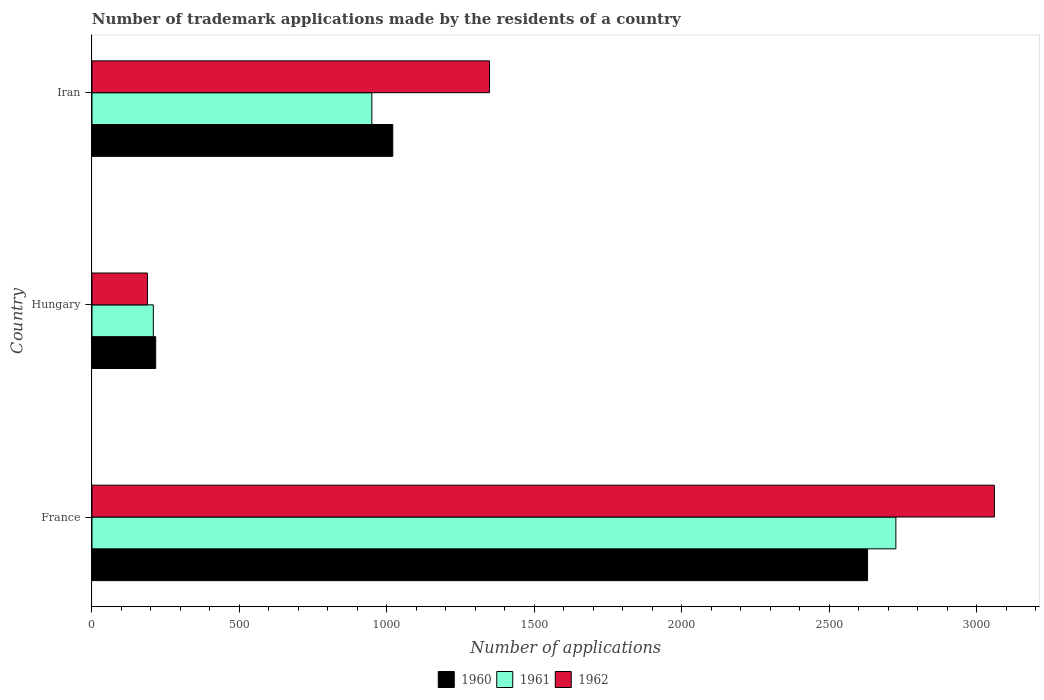Are the number of bars on each tick of the Y-axis equal?
Your answer should be compact. Yes. How many bars are there on the 3rd tick from the top?
Ensure brevity in your answer.  3. How many bars are there on the 2nd tick from the bottom?
Your answer should be very brief. 3. What is the label of the 1st group of bars from the top?
Offer a terse response. Iran. What is the number of trademark applications made by the residents in 1961 in France?
Offer a very short reply. 2726. Across all countries, what is the maximum number of trademark applications made by the residents in 1960?
Keep it short and to the point. 2630. Across all countries, what is the minimum number of trademark applications made by the residents in 1962?
Your answer should be very brief. 188. In which country was the number of trademark applications made by the residents in 1962 maximum?
Give a very brief answer. France. In which country was the number of trademark applications made by the residents in 1961 minimum?
Provide a succinct answer. Hungary. What is the total number of trademark applications made by the residents in 1960 in the graph?
Your answer should be compact. 3866. What is the difference between the number of trademark applications made by the residents in 1962 in Hungary and that in Iran?
Offer a terse response. -1160. What is the difference between the number of trademark applications made by the residents in 1960 in France and the number of trademark applications made by the residents in 1961 in Hungary?
Make the answer very short. 2422. What is the average number of trademark applications made by the residents in 1961 per country?
Offer a very short reply. 1294.33. What is the difference between the number of trademark applications made by the residents in 1962 and number of trademark applications made by the residents in 1961 in Iran?
Keep it short and to the point. 399. In how many countries, is the number of trademark applications made by the residents in 1961 greater than 500 ?
Ensure brevity in your answer.  2. What is the ratio of the number of trademark applications made by the residents in 1960 in France to that in Hungary?
Your answer should be compact. 12.18. Is the number of trademark applications made by the residents in 1960 in France less than that in Hungary?
Ensure brevity in your answer.  No. What is the difference between the highest and the second highest number of trademark applications made by the residents in 1961?
Offer a terse response. 1777. What is the difference between the highest and the lowest number of trademark applications made by the residents in 1961?
Make the answer very short. 2518. In how many countries, is the number of trademark applications made by the residents in 1962 greater than the average number of trademark applications made by the residents in 1962 taken over all countries?
Keep it short and to the point. 1. What does the 2nd bar from the top in Hungary represents?
Your answer should be very brief. 1961. Is it the case that in every country, the sum of the number of trademark applications made by the residents in 1962 and number of trademark applications made by the residents in 1961 is greater than the number of trademark applications made by the residents in 1960?
Offer a terse response. Yes. What is the difference between two consecutive major ticks on the X-axis?
Your answer should be compact. 500. Are the values on the major ticks of X-axis written in scientific E-notation?
Your response must be concise. No. Does the graph contain grids?
Your response must be concise. No. Where does the legend appear in the graph?
Offer a very short reply. Bottom center. What is the title of the graph?
Provide a succinct answer. Number of trademark applications made by the residents of a country. What is the label or title of the X-axis?
Make the answer very short. Number of applications. What is the Number of applications of 1960 in France?
Make the answer very short. 2630. What is the Number of applications of 1961 in France?
Your answer should be compact. 2726. What is the Number of applications in 1962 in France?
Your answer should be compact. 3060. What is the Number of applications of 1960 in Hungary?
Give a very brief answer. 216. What is the Number of applications in 1961 in Hungary?
Keep it short and to the point. 208. What is the Number of applications in 1962 in Hungary?
Offer a very short reply. 188. What is the Number of applications of 1960 in Iran?
Make the answer very short. 1020. What is the Number of applications in 1961 in Iran?
Keep it short and to the point. 949. What is the Number of applications of 1962 in Iran?
Make the answer very short. 1348. Across all countries, what is the maximum Number of applications of 1960?
Keep it short and to the point. 2630. Across all countries, what is the maximum Number of applications of 1961?
Provide a short and direct response. 2726. Across all countries, what is the maximum Number of applications of 1962?
Offer a very short reply. 3060. Across all countries, what is the minimum Number of applications in 1960?
Make the answer very short. 216. Across all countries, what is the minimum Number of applications of 1961?
Provide a succinct answer. 208. Across all countries, what is the minimum Number of applications in 1962?
Ensure brevity in your answer.  188. What is the total Number of applications of 1960 in the graph?
Make the answer very short. 3866. What is the total Number of applications in 1961 in the graph?
Keep it short and to the point. 3883. What is the total Number of applications of 1962 in the graph?
Provide a short and direct response. 4596. What is the difference between the Number of applications in 1960 in France and that in Hungary?
Provide a succinct answer. 2414. What is the difference between the Number of applications of 1961 in France and that in Hungary?
Make the answer very short. 2518. What is the difference between the Number of applications in 1962 in France and that in Hungary?
Give a very brief answer. 2872. What is the difference between the Number of applications of 1960 in France and that in Iran?
Give a very brief answer. 1610. What is the difference between the Number of applications in 1961 in France and that in Iran?
Provide a short and direct response. 1777. What is the difference between the Number of applications of 1962 in France and that in Iran?
Give a very brief answer. 1712. What is the difference between the Number of applications of 1960 in Hungary and that in Iran?
Provide a succinct answer. -804. What is the difference between the Number of applications in 1961 in Hungary and that in Iran?
Your answer should be compact. -741. What is the difference between the Number of applications of 1962 in Hungary and that in Iran?
Your response must be concise. -1160. What is the difference between the Number of applications in 1960 in France and the Number of applications in 1961 in Hungary?
Give a very brief answer. 2422. What is the difference between the Number of applications in 1960 in France and the Number of applications in 1962 in Hungary?
Provide a succinct answer. 2442. What is the difference between the Number of applications of 1961 in France and the Number of applications of 1962 in Hungary?
Your response must be concise. 2538. What is the difference between the Number of applications in 1960 in France and the Number of applications in 1961 in Iran?
Offer a very short reply. 1681. What is the difference between the Number of applications in 1960 in France and the Number of applications in 1962 in Iran?
Offer a terse response. 1282. What is the difference between the Number of applications in 1961 in France and the Number of applications in 1962 in Iran?
Offer a terse response. 1378. What is the difference between the Number of applications of 1960 in Hungary and the Number of applications of 1961 in Iran?
Make the answer very short. -733. What is the difference between the Number of applications in 1960 in Hungary and the Number of applications in 1962 in Iran?
Keep it short and to the point. -1132. What is the difference between the Number of applications in 1961 in Hungary and the Number of applications in 1962 in Iran?
Provide a succinct answer. -1140. What is the average Number of applications of 1960 per country?
Offer a very short reply. 1288.67. What is the average Number of applications of 1961 per country?
Your response must be concise. 1294.33. What is the average Number of applications in 1962 per country?
Offer a very short reply. 1532. What is the difference between the Number of applications in 1960 and Number of applications in 1961 in France?
Keep it short and to the point. -96. What is the difference between the Number of applications of 1960 and Number of applications of 1962 in France?
Your answer should be compact. -430. What is the difference between the Number of applications in 1961 and Number of applications in 1962 in France?
Your response must be concise. -334. What is the difference between the Number of applications in 1960 and Number of applications in 1961 in Hungary?
Provide a short and direct response. 8. What is the difference between the Number of applications of 1960 and Number of applications of 1962 in Iran?
Make the answer very short. -328. What is the difference between the Number of applications of 1961 and Number of applications of 1962 in Iran?
Offer a very short reply. -399. What is the ratio of the Number of applications in 1960 in France to that in Hungary?
Your answer should be very brief. 12.18. What is the ratio of the Number of applications of 1961 in France to that in Hungary?
Keep it short and to the point. 13.11. What is the ratio of the Number of applications of 1962 in France to that in Hungary?
Ensure brevity in your answer.  16.28. What is the ratio of the Number of applications in 1960 in France to that in Iran?
Give a very brief answer. 2.58. What is the ratio of the Number of applications of 1961 in France to that in Iran?
Your answer should be very brief. 2.87. What is the ratio of the Number of applications of 1962 in France to that in Iran?
Offer a very short reply. 2.27. What is the ratio of the Number of applications in 1960 in Hungary to that in Iran?
Ensure brevity in your answer.  0.21. What is the ratio of the Number of applications of 1961 in Hungary to that in Iran?
Your response must be concise. 0.22. What is the ratio of the Number of applications in 1962 in Hungary to that in Iran?
Offer a terse response. 0.14. What is the difference between the highest and the second highest Number of applications in 1960?
Your response must be concise. 1610. What is the difference between the highest and the second highest Number of applications in 1961?
Make the answer very short. 1777. What is the difference between the highest and the second highest Number of applications of 1962?
Keep it short and to the point. 1712. What is the difference between the highest and the lowest Number of applications in 1960?
Make the answer very short. 2414. What is the difference between the highest and the lowest Number of applications in 1961?
Your answer should be compact. 2518. What is the difference between the highest and the lowest Number of applications of 1962?
Keep it short and to the point. 2872. 